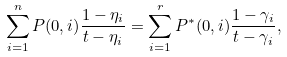Convert formula to latex. <formula><loc_0><loc_0><loc_500><loc_500>\sum _ { i = 1 } ^ { n } P ( 0 , i ) \frac { 1 - \eta _ { i } } { t - \eta _ { i } } = \sum _ { i = 1 } ^ { r } P ^ { * } ( 0 , i ) \frac { 1 - \gamma _ { i } } { t - \gamma _ { i } } ,</formula> 